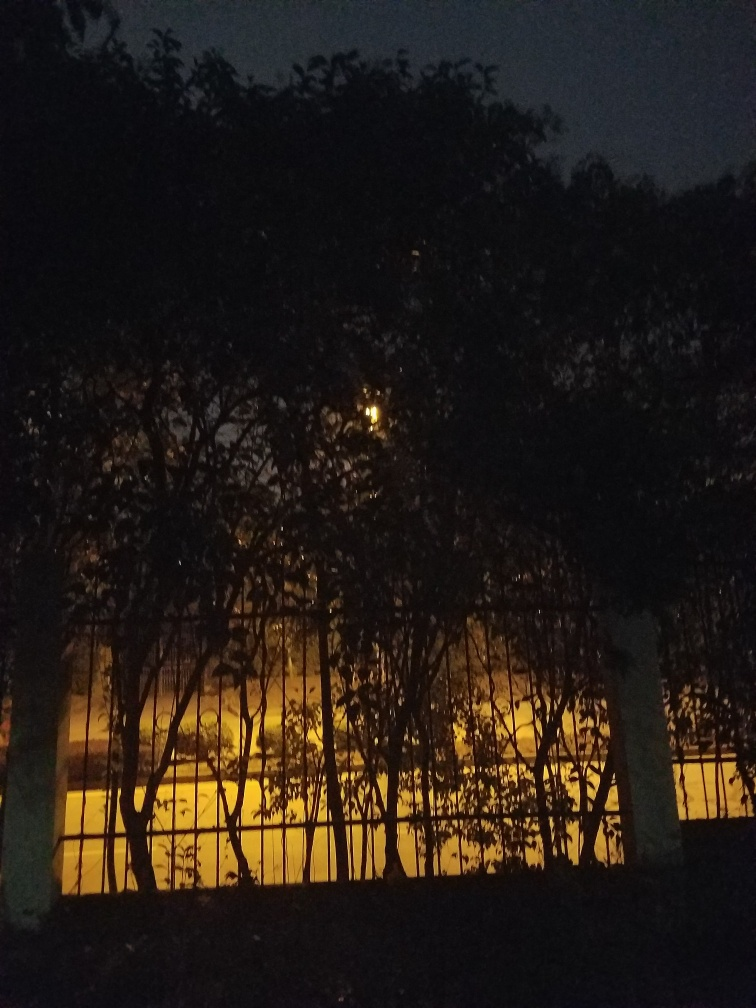Can you describe the atmosphere or mood of this setting? The image evokes a calm and perhaps mysterious ambiance. The warm light contrasting with the dark silhouette of the trees creates a boundary between the known and the unknown. It might suggest serenity, with a touch of solitude, or even a slightly eerie undertone, depending on the viewer's perception. 